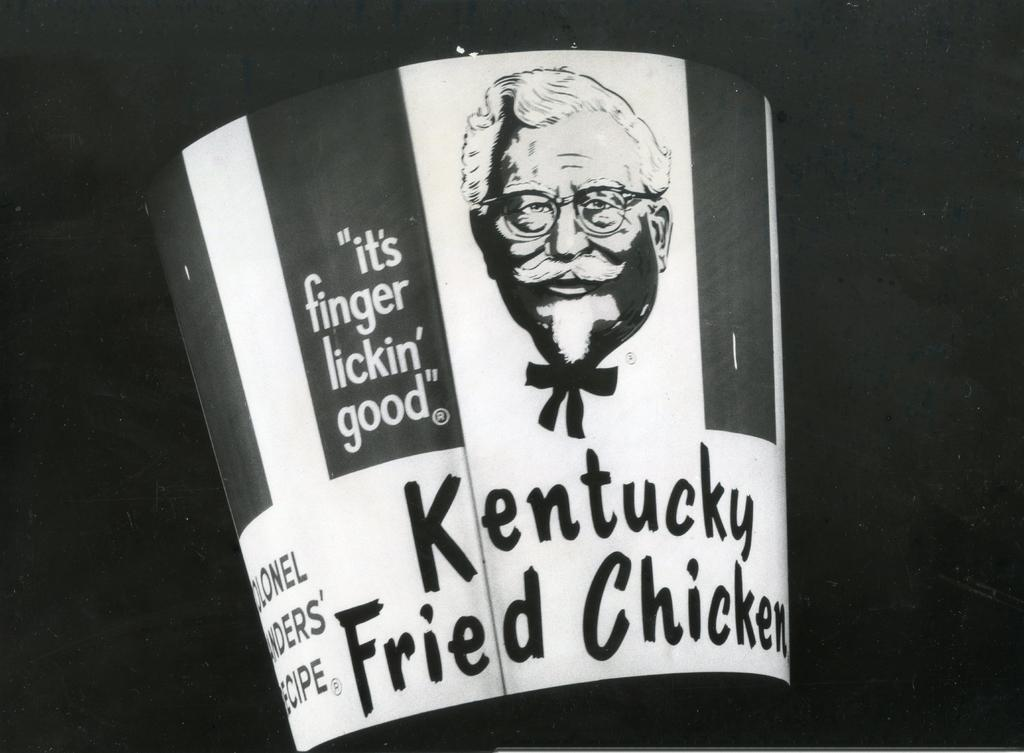What object is placed on the black surface in the image? There is a bucket placed on a black surface in the image. What else can be seen on the black surface besides the bucket? There is a picture of a person and some text on the black surface. What type of pest can be seen crawling on the bucket in the image? There are no pests visible in the image; it only shows a bucket, a picture of a person, and some text on a black surface. 